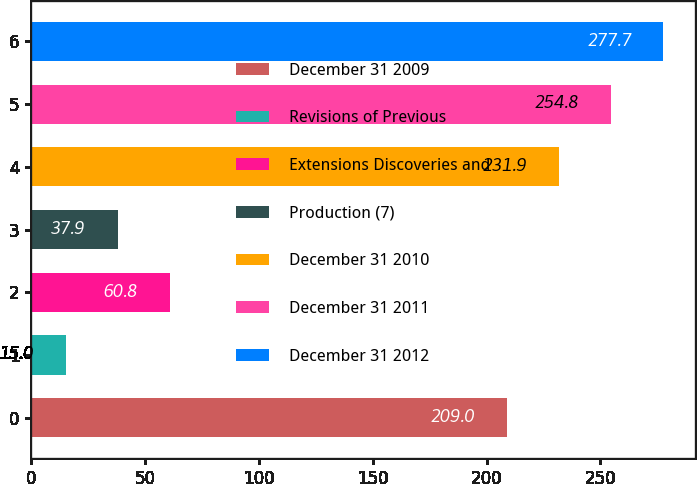<chart> <loc_0><loc_0><loc_500><loc_500><bar_chart><fcel>December 31 2009<fcel>Revisions of Previous<fcel>Extensions Discoveries and<fcel>Production (7)<fcel>December 31 2010<fcel>December 31 2011<fcel>December 31 2012<nl><fcel>209<fcel>15<fcel>60.8<fcel>37.9<fcel>231.9<fcel>254.8<fcel>277.7<nl></chart> 